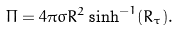Convert formula to latex. <formula><loc_0><loc_0><loc_500><loc_500>\Pi = 4 \pi \sigma R ^ { 2 } \sinh ^ { - 1 } ( R _ { \tau } ) .</formula> 